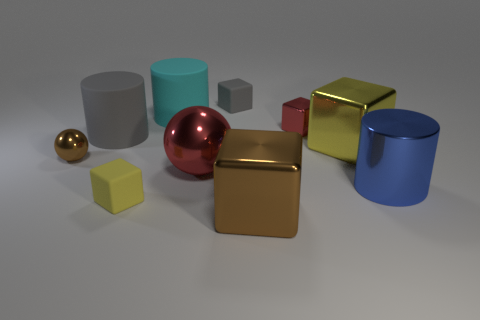Can you describe the lighting in the image? The image features a soft overhead lighting that casts gentle shadows beneath each object. The lighting appears diffuse, suggesting an indoor environment possibly lit by studio lights or a window out of view, which allows for the objects' textures and colors to be distinctly visible. 